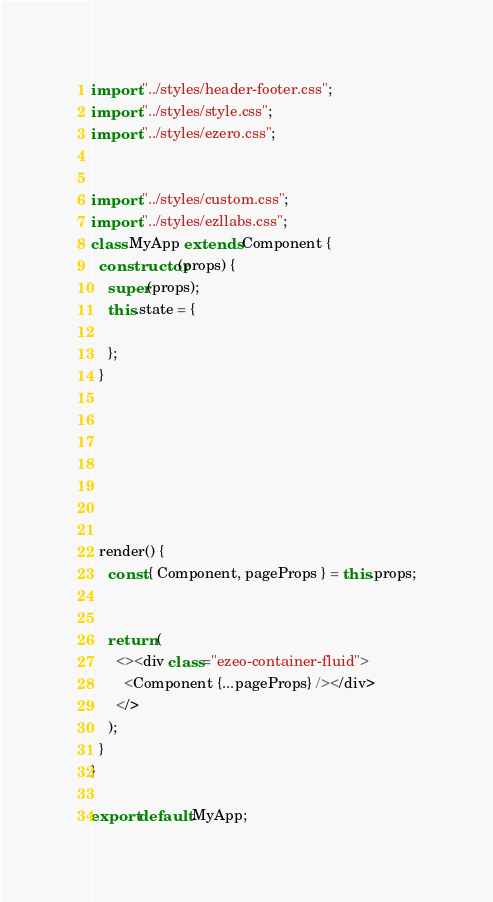<code> <loc_0><loc_0><loc_500><loc_500><_JavaScript_>import "../styles/header-footer.css";
import "../styles/style.css";
import "../styles/ezero.css";


import "../styles/custom.css";
import "../styles/ezllabs.css";
class MyApp extends Component {
  constructor(props) {
    super(props);
    this.state = {

    };
  }







  render() {
    const { Component, pageProps } = this.props;


    return (
      <><div class="ezeo-container-fluid">
        <Component {...pageProps} /></div>
      </>
    );
  }
}

export default MyApp;
</code> 